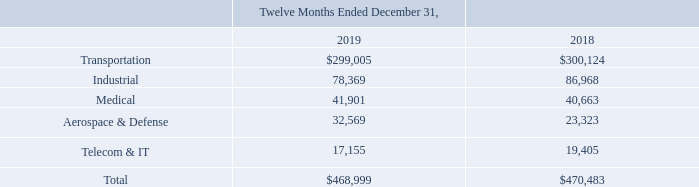NOTES TO CONSOLIDATED FINANCIAL STATEMENTS (in thousands, except for share and per share data)
Disaggregated Revenue
The following table presents revenues disaggregated by the major markets we serve:
Which years does the table provide information for revenues disaggregated by the major markets the company ser ves? 2019, 2018. What was the revenue from Industrial in 2019?
Answer scale should be: thousand. 78,369. What was the revenue from Telecom & IT in 2018?
Answer scale should be: thousand. 19,405. Which major markets had revenues that exceeded $100,000 thousand in 2019? (Transportation:299,005)
Answer: transportation. What was the change in the revenues from Aerospace & Defense between 2018 and 2019?
Answer scale should be: thousand. 32,569-23,323
Answer: 9246. What was the percentage change in total revenue between 2018 and 2019?
Answer scale should be: percent. (468,999-470,483)/470,483
Answer: -0.32. 